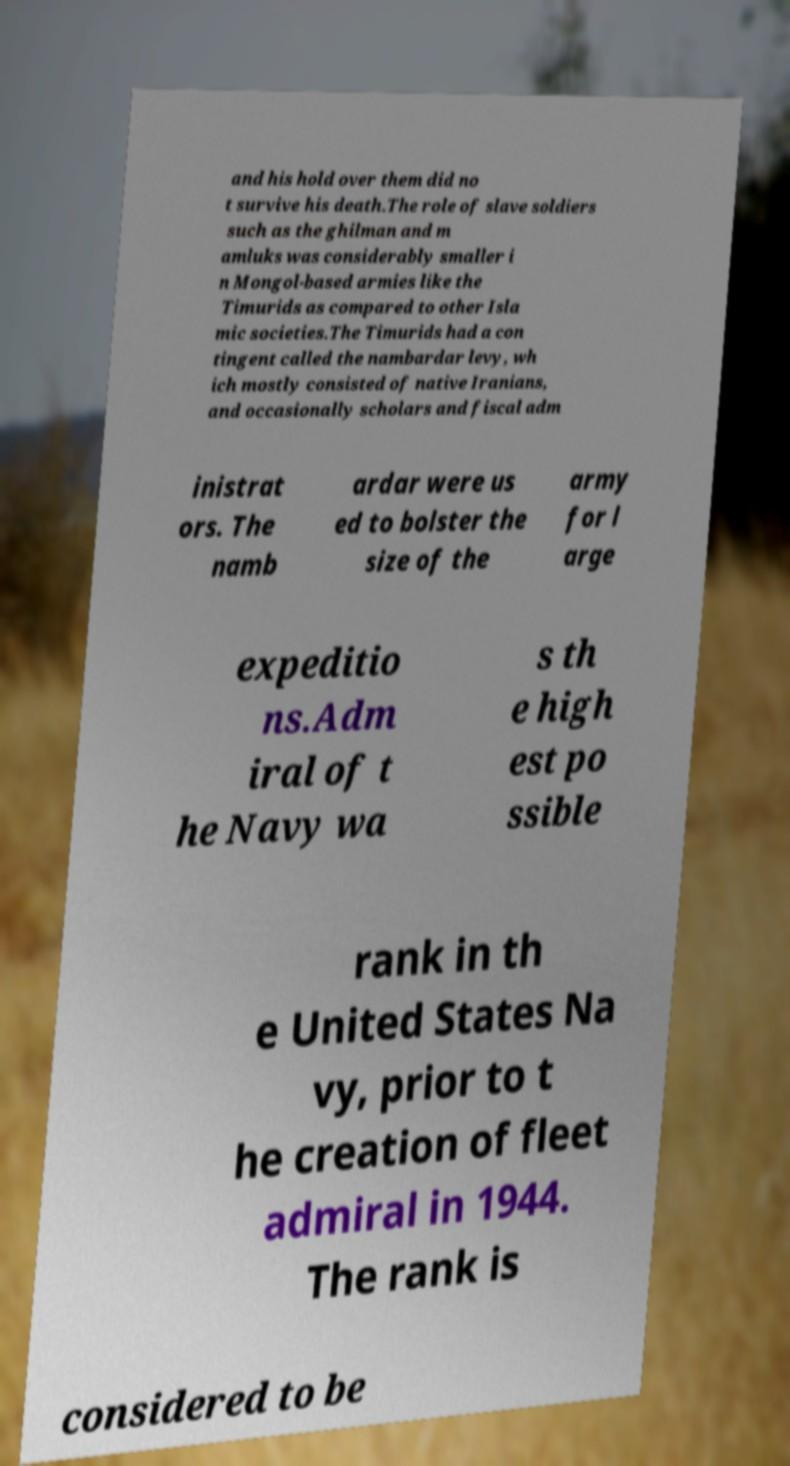Can you accurately transcribe the text from the provided image for me? and his hold over them did no t survive his death.The role of slave soldiers such as the ghilman and m amluks was considerably smaller i n Mongol-based armies like the Timurids as compared to other Isla mic societies.The Timurids had a con tingent called the nambardar levy, wh ich mostly consisted of native Iranians, and occasionally scholars and fiscal adm inistrat ors. The namb ardar were us ed to bolster the size of the army for l arge expeditio ns.Adm iral of t he Navy wa s th e high est po ssible rank in th e United States Na vy, prior to t he creation of fleet admiral in 1944. The rank is considered to be 